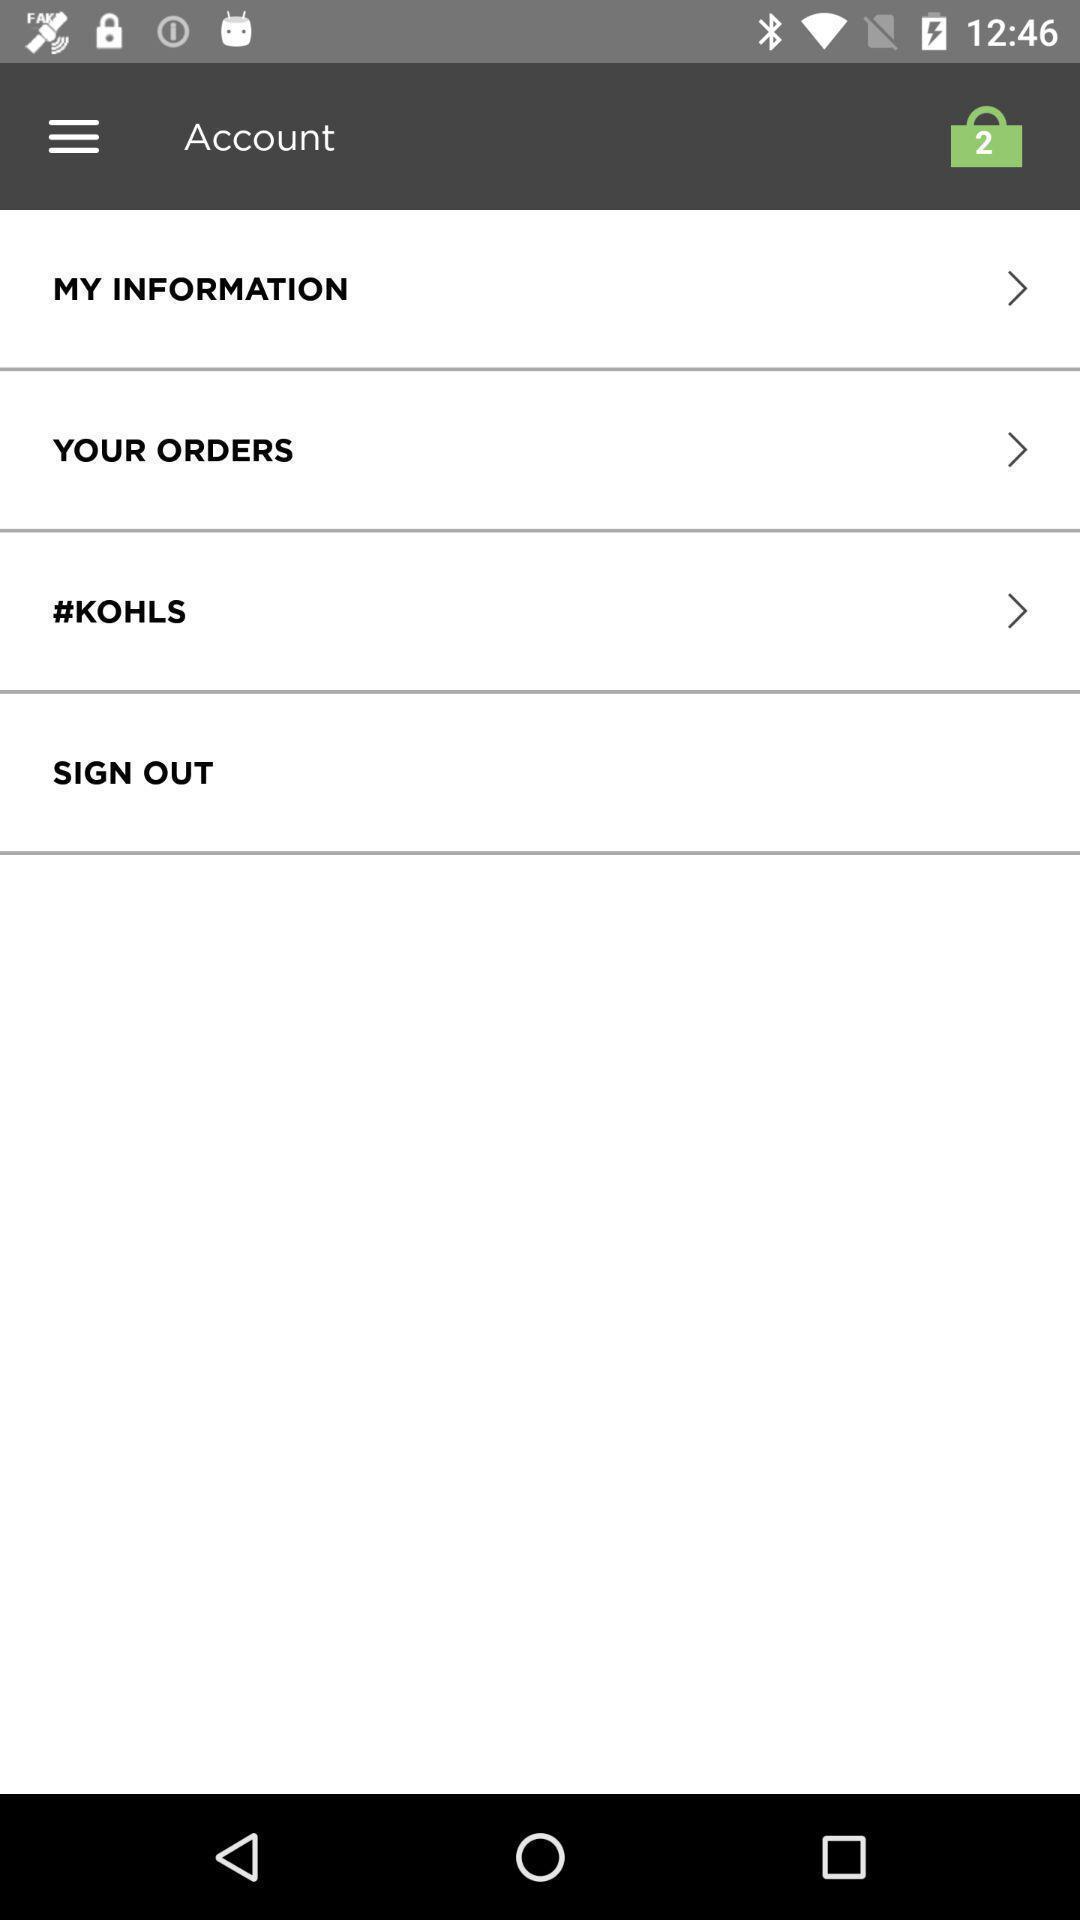Summarize the main components in this picture. Page displaying the information and orders of an account. 